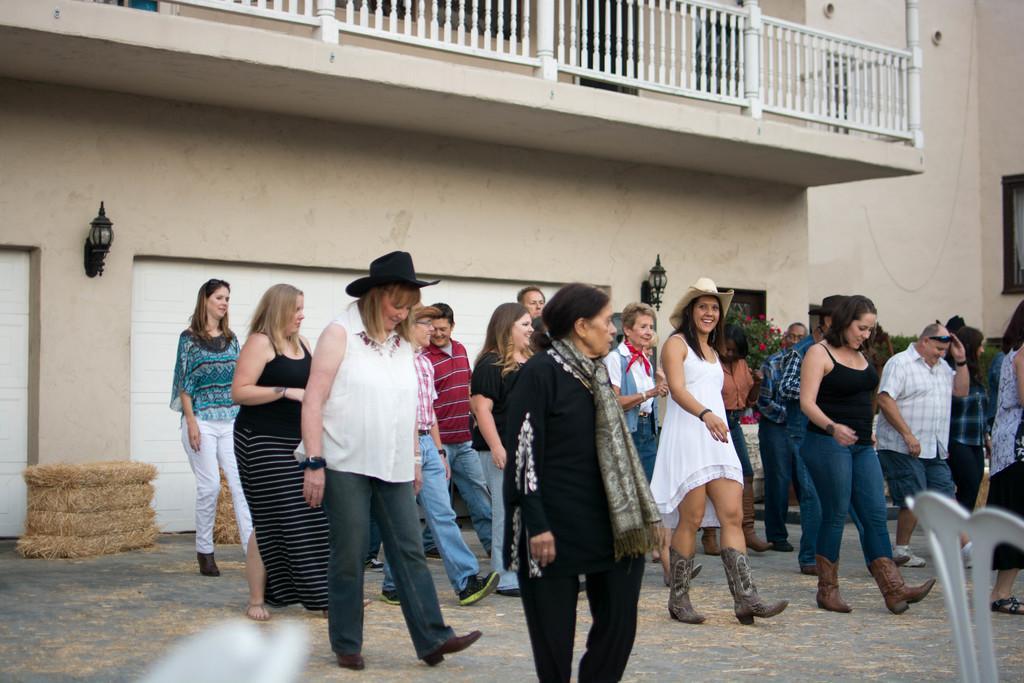Could you give a brief overview of what you see in this image? In this image, we can see a group of people are walking on the ground. Few are smiling. Background there is a wall, grass bunches, plants, flowers, lights on the wall. Top of the image, there is a railing, windows and pole. 